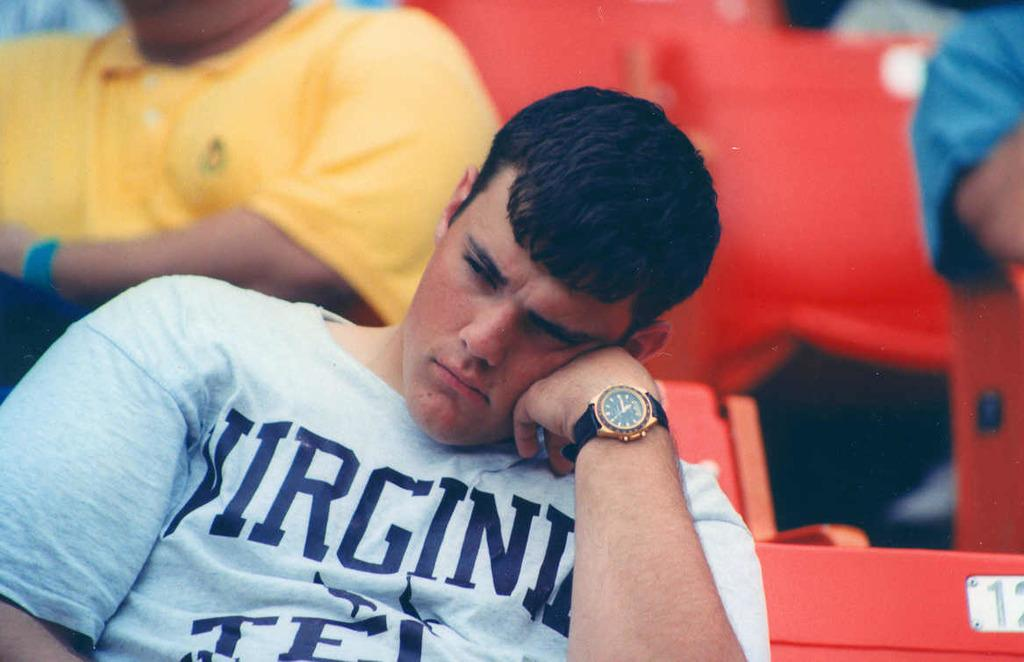<image>
Give a short and clear explanation of the subsequent image. A man with black hair has Virginia written upon his shirt. 